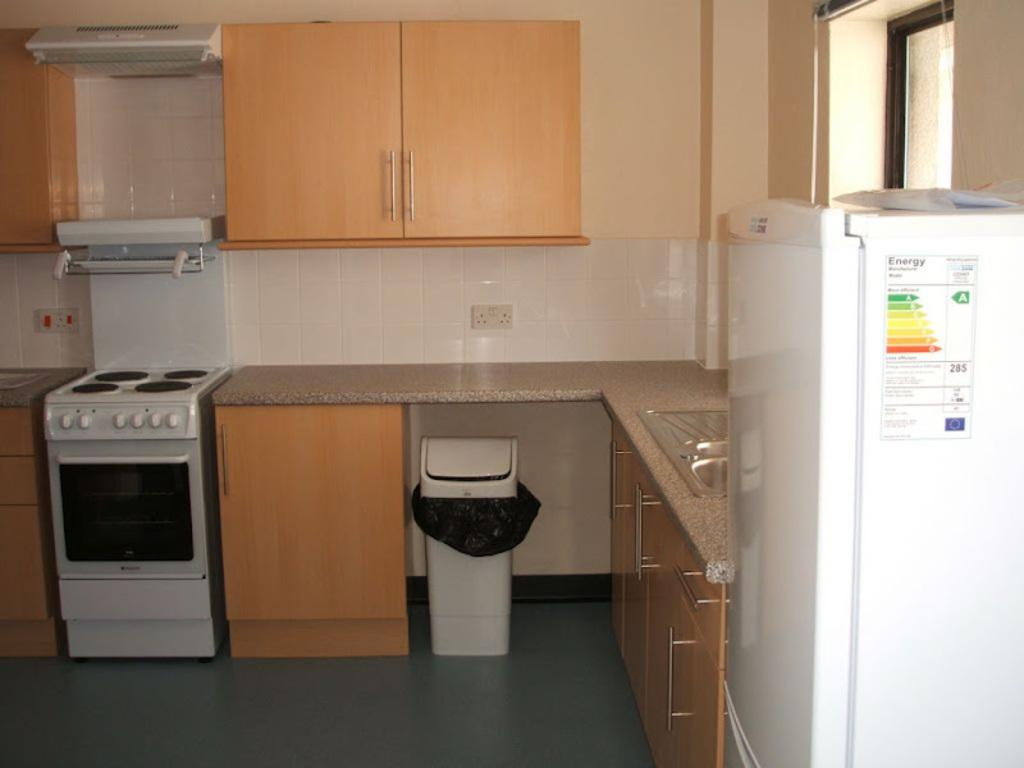<image>
Create a compact narrative representing the image presented. the word energy is on the side of a fridge 